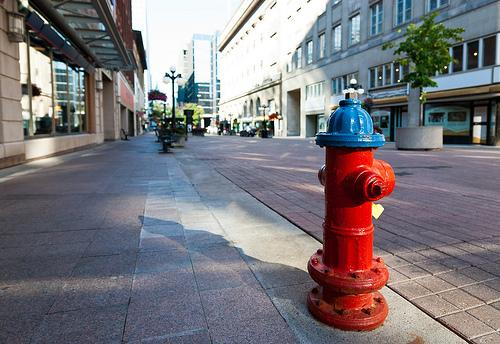What type of light condition is shown for the lamp post in the image? The lamp post is off, suggesting that it is daytime. What type of flooring is surrounding the fire hydrant? The flooring surrounding the fire hydrant is brick pavers. Identify the color of the fire hydrant and its top. The fire hydrant is red, and its top is blue. Can you describe the green object on the image? There is a green tree growing in a cement planter along the walkway. Analyze the sentiment of the image with the given annotations. It's a pleasant day in a lively downtown area with well-maintained surroundings such as sidewalks, stores, and streetlights. State the location of the fire hydrant in the image and describe its shadow. The fire hydrant is on the sidewalk, and it casts a long shadow on the brick pavers. Mention a few elements you can find along the walkway in the image. Along the walkway, there are stores, street lights, benches, trees, and a fire hydrant. Describe a reasoning task related to the fire hydrant's location in the context of the image. Understand the importance of having fire hydrants in downtown areas for fire emergencies, as they provide quick access to water for firefighting. What type of anomalies could be found in this image? There are no apparent anomalies in the image. Name a few elements that are associated with a downtown city scene in the image. Skyscrapers, glass buildings, windows, lights, advertisements, and awning on the building. 